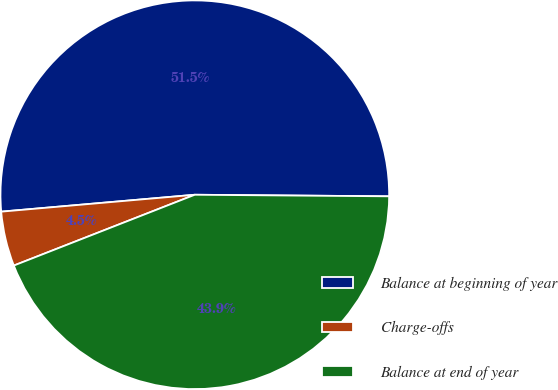Convert chart to OTSL. <chart><loc_0><loc_0><loc_500><loc_500><pie_chart><fcel>Balance at beginning of year<fcel>Charge-offs<fcel>Balance at end of year<nl><fcel>51.52%<fcel>4.55%<fcel>43.94%<nl></chart> 